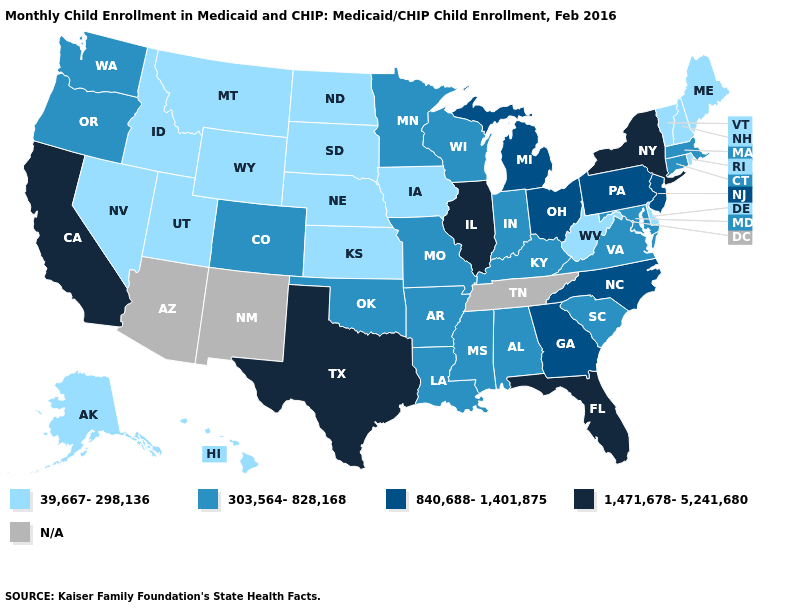Does New Jersey have the lowest value in the USA?
Concise answer only. No. Does New Hampshire have the highest value in the Northeast?
Be succinct. No. Does New York have the highest value in the Northeast?
Short answer required. Yes. What is the value of West Virginia?
Short answer required. 39,667-298,136. What is the value of Montana?
Keep it brief. 39,667-298,136. What is the value of Alabama?
Quick response, please. 303,564-828,168. Name the states that have a value in the range 1,471,678-5,241,680?
Quick response, please. California, Florida, Illinois, New York, Texas. Among the states that border Utah , does Colorado have the lowest value?
Answer briefly. No. Name the states that have a value in the range 1,471,678-5,241,680?
Answer briefly. California, Florida, Illinois, New York, Texas. What is the lowest value in the USA?
Be succinct. 39,667-298,136. What is the value of Arkansas?
Concise answer only. 303,564-828,168. Does the map have missing data?
Write a very short answer. Yes. What is the value of Mississippi?
Answer briefly. 303,564-828,168. 